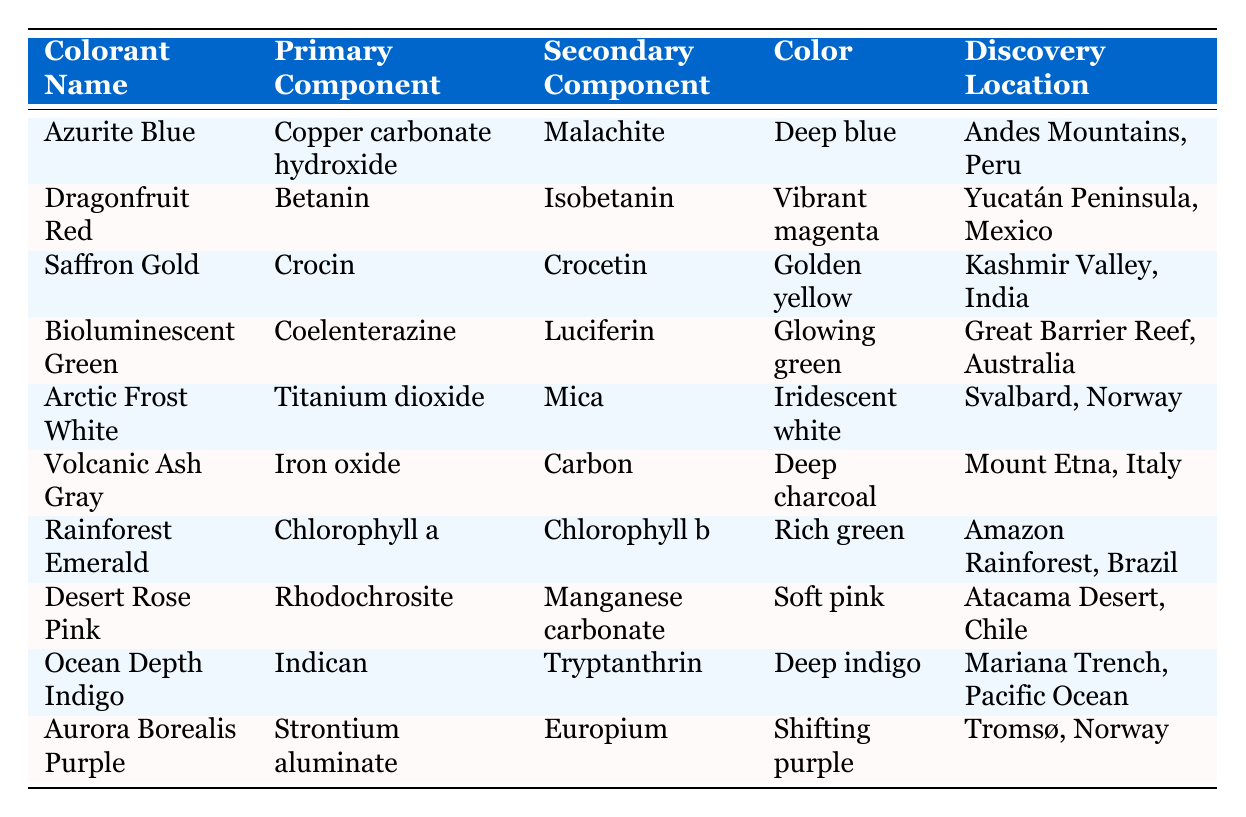What is the primary component of Dragonfruit Red? Dragonfruit Red is listed in the table with its corresponding primary component. By looking at the row for Dragonfruit Red, we see that the primary component is Betanin.
Answer: Betanin Which colorant has the color "Glowing green"? The table lists the colorants along with their respective colors. By scanning the color column for "Glowing green", we find that it corresponds to the colorant Bioluminescent Green.
Answer: Bioluminescent Green Are any colorants discovered in Norway? To answer this, we can check the Discovery Location column for any entries that mention Norway. The table lists Arctic Frost White and Aurora Borealis Purple, both of which were discovered in Norway. Therefore, the answer is yes.
Answer: Yes What is the secondary component of Rainforest Emerald? According to the table, which shows the details of Rainforest Emerald, the secondary component is Chlorophyll b.
Answer: Chlorophyll b Which colorant has the deepest shade of color? To determine this, we analyze the colors in the color column, focusing on descriptors that imply depth. The color "Deep indigo" from Ocean Depth Indigo suggests it is the deepest shade, compared to the others listed.
Answer: Ocean Depth Indigo How many colorants contain Chlorophyll as a component? We need to look for any colorant that lists Chlorophyll in either the primary or secondary component columns. The only instance found is Rainforest Emerald, which contains Chlorophyll a and b. Since there's only one colorant, the answer is one.
Answer: One Which colorant has the component "Iron oxide"? The table can be referenced by locating the entry with Iron oxide. It is found in the row for Volcanic Ash Gray, so this colorant corresponds to Iron oxide.
Answer: Volcanic Ash Gray What two colorants are associated with the color green? We need to identify all entries in the color column containing green, which are Bioluminescent Green and Rainforest Emerald. Summarizing both colorants, these are the instances with green hues.
Answer: Bioluminescent Green, Rainforest Emerald Which discovery location has the most associated colorants according to the table? We analyze the Discovery Location column. Each location is compared based on the number of occurrences. There are no duplicates, and each location corresponds to one unique colorant; hence no single location has more than one. Therefore, none is more than the others.
Answer: None 